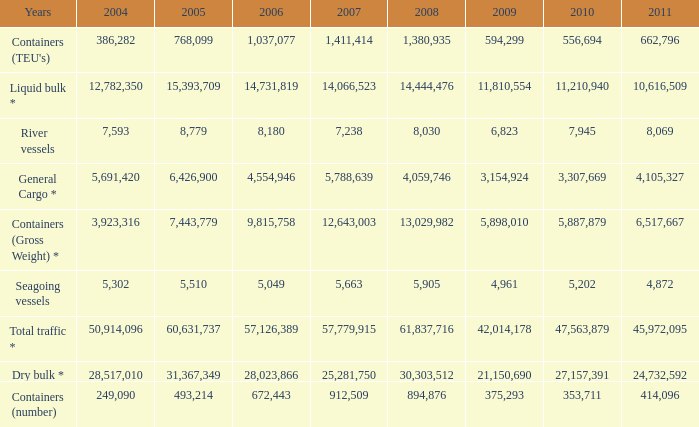What is the highest value in 2011 with less than 5,049 in 2006 and less than 1,380,935 in 2008? None. I'm looking to parse the entire table for insights. Could you assist me with that? {'header': ['Years', '2004', '2005', '2006', '2007', '2008', '2009', '2010', '2011'], 'rows': [["Containers (TEU's)", '386,282', '768,099', '1,037,077', '1,411,414', '1,380,935', '594,299', '556,694', '662,796'], ['Liquid bulk *', '12,782,350', '15,393,709', '14,731,819', '14,066,523', '14,444,476', '11,810,554', '11,210,940', '10,616,509'], ['River vessels', '7,593', '8,779', '8,180', '7,238', '8,030', '6,823', '7,945', '8,069'], ['General Cargo *', '5,691,420', '6,426,900', '4,554,946', '5,788,639', '4,059,746', '3,154,924', '3,307,669', '4,105,327'], ['Containers (Gross Weight) *', '3,923,316', '7,443,779', '9,815,758', '12,643,003', '13,029,982', '5,898,010', '5,887,879', '6,517,667'], ['Seagoing vessels', '5,302', '5,510', '5,049', '5,663', '5,905', '4,961', '5,202', '4,872'], ['Total traffic *', '50,914,096', '60,631,737', '57,126,389', '57,779,915', '61,837,716', '42,014,178', '47,563,879', '45,972,095'], ['Dry bulk *', '28,517,010', '31,367,349', '28,023,866', '25,281,750', '30,303,512', '21,150,690', '27,157,391', '24,732,592'], ['Containers (number)', '249,090', '493,214', '672,443', '912,509', '894,876', '375,293', '353,711', '414,096']]} 